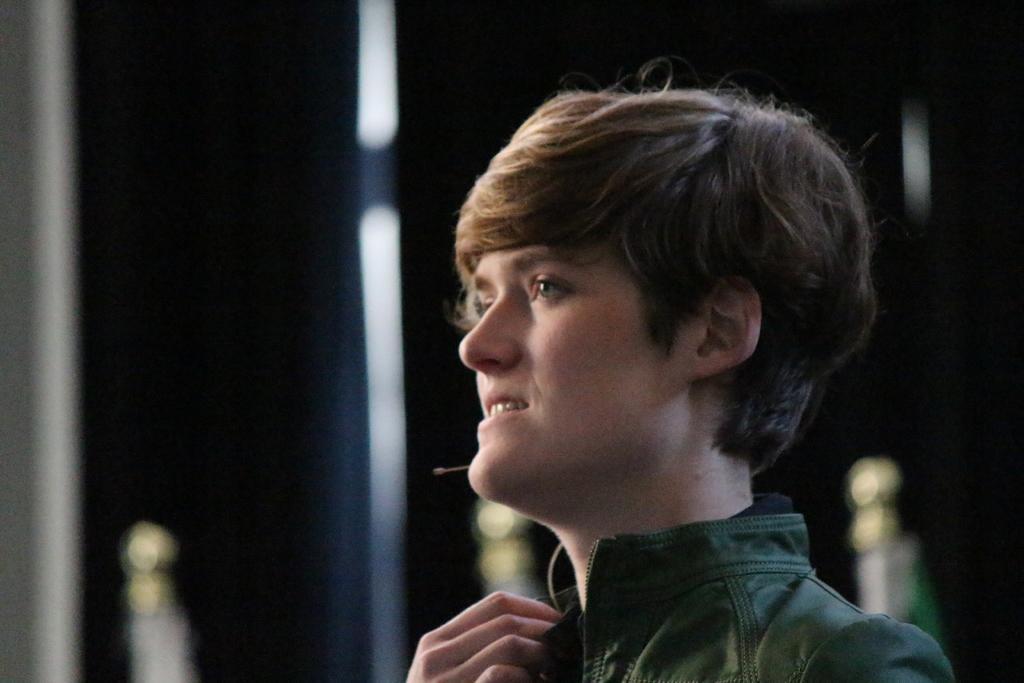Could you give a brief overview of what you see in this image? There is a person in jacket, smiling. And the background is blurred. 